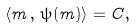Convert formula to latex. <formula><loc_0><loc_0><loc_500><loc_500>\langle m \, , \, \psi ( m ) \rangle = C ,</formula> 